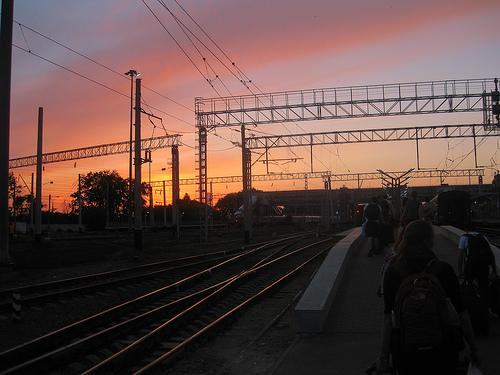Identify any object interactions in the image. The train is coming on the rail road while people are walking near the tracks. Express the atmosphere of the image in a poetic manner. Underneath the multicolored sky, lives intertwine; trains traverse the tracks, and people meander, as backpacks carry the weight of their journey.  What emotion or sentiment can be associated with the image, given its various elements? The sentiment of the image can be described as busy and dynamic, with people walking and the train approaching. List five objects that can be found in this image. rail road, backpack, tracks, sky, people Based on the image's content, can you deduce any specific location or setting for the scene? The image likely depicts an outdoor train station or railway crossing, with people walking and carrying backpacks nearby. In simple terms, describe an interesting event taking place in the image. There's a train coming on the rail road, and people are walking nearby. Identify the object attributes for the girl in the image. The girl has hair. Describe the interaction between the backpacks and the people in the image. There is not enough information to determine the interaction between the backpacks and the people. Segment the image into its semantic components and describe each object with its characteristics. railroad - horizontal lines intersecting each other, backpack - different sizes, the sky - multicolored, people - walking, light - on, concrete - gray, white shirt, metal structure, train -coming, pole - thick, girl - has hair In which part of the image are the people the smallest? Top, middle, or bottom? Top Which objects have the smallest width and height in the image? the girl has hair (Width:17, Height:17) and the pole is thick (Width:27, Height:27) Assess the quality of the image based on the objects' sizes and positions. The image quality is acceptable with clear objects and distinct positions. Is the rail road green and covered with grass? The instruction is misleading as it mentions an attribute (green and covered with grass) that is not related to a rail road, which is typically made of metal and wood. Describe the image in terms of the objects present and their positions. The image contains railroads, a backpack, the sky, people walking, a light, concrete, a white shirt, a metal structure, a train, a thick pole, and a girl with hair at various positions and sizes. Determine the color of the shirt in the image. White Is there a pole made of rubber that can be bent easily? Poles are usually made of sturdy materials like metal or wood. By asking about a rubber pole that can be bent, the instruction misleads users about the object's expected attributes. What is the largest object in terms of width and height in the image? the structure is metal (Width:312, Height:312) Analyze the interaction between the train and the railroad in the image. The train is coming towards the railroad, suggesting it is about to move on the tracks. Express your impression of the image in one sentence. The image seems to depict a busy day at a train station with various objects and people interacting. Identify the position of the light that is turned on. X:122, Y:59, Width:37, Height:37 Extract any text visible within the image. No text can be found in the image. Evaluate the overall sentiment of the image. Neutral Which objects are located near the bottom left corner of the image? the rail road and the thick pole Is there a shirt that is transparent and floating in the air? The instruction is misleading because it describes a shirt with attributes (transparent and floating) that are not usually associated with a shirt. Can you find a train that is invisible and moving on water? The instruction is misleading because it combines two improbable attributes (invisible and moving on water) for a train, which typically runs on tracks and is clearly visible. Does the sky have a perfect geometric pattern with triangles and circles? A sky is typically described with colors or natural patterns like clouds. The presence of a geometric pattern is not relevant and creates confusion about the sky's attributes. Can you see a backpack made of glass in the image? Glass is not a typical material used for making backpacks. This instruction confuses the user by inquiring about an object with an improbable attribute (made of glass). Choose the correct answer: How many backpacks are in the image? A) 3 B) 4 C) 5 D) 6 C) 5 